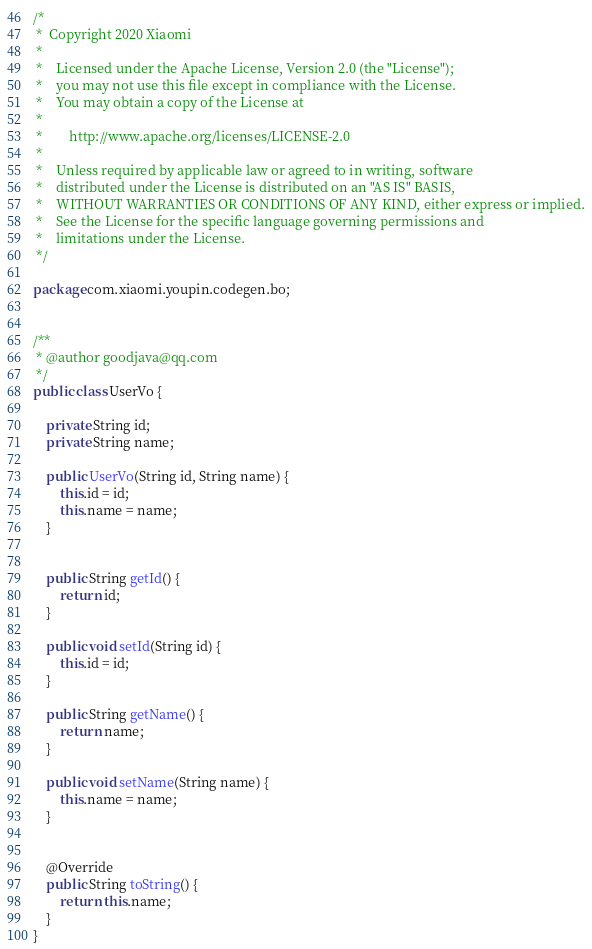<code> <loc_0><loc_0><loc_500><loc_500><_Java_>/*
 *  Copyright 2020 Xiaomi
 *
 *    Licensed under the Apache License, Version 2.0 (the "License");
 *    you may not use this file except in compliance with the License.
 *    You may obtain a copy of the License at
 *
 *        http://www.apache.org/licenses/LICENSE-2.0
 *
 *    Unless required by applicable law or agreed to in writing, software
 *    distributed under the License is distributed on an "AS IS" BASIS,
 *    WITHOUT WARRANTIES OR CONDITIONS OF ANY KIND, either express or implied.
 *    See the License for the specific language governing permissions and
 *    limitations under the License.
 */

package com.xiaomi.youpin.codegen.bo;


/**
 * @author goodjava@qq.com
 */
public class UserVo {

    private String id;
    private String name;

    public UserVo(String id, String name) {
        this.id = id;
        this.name = name;
    }


    public String getId() {
        return id;
    }

    public void setId(String id) {
        this.id = id;
    }

    public String getName() {
        return name;
    }

    public void setName(String name) {
        this.name = name;
    }


    @Override
    public String toString() {
        return this.name;
    }
}
</code> 